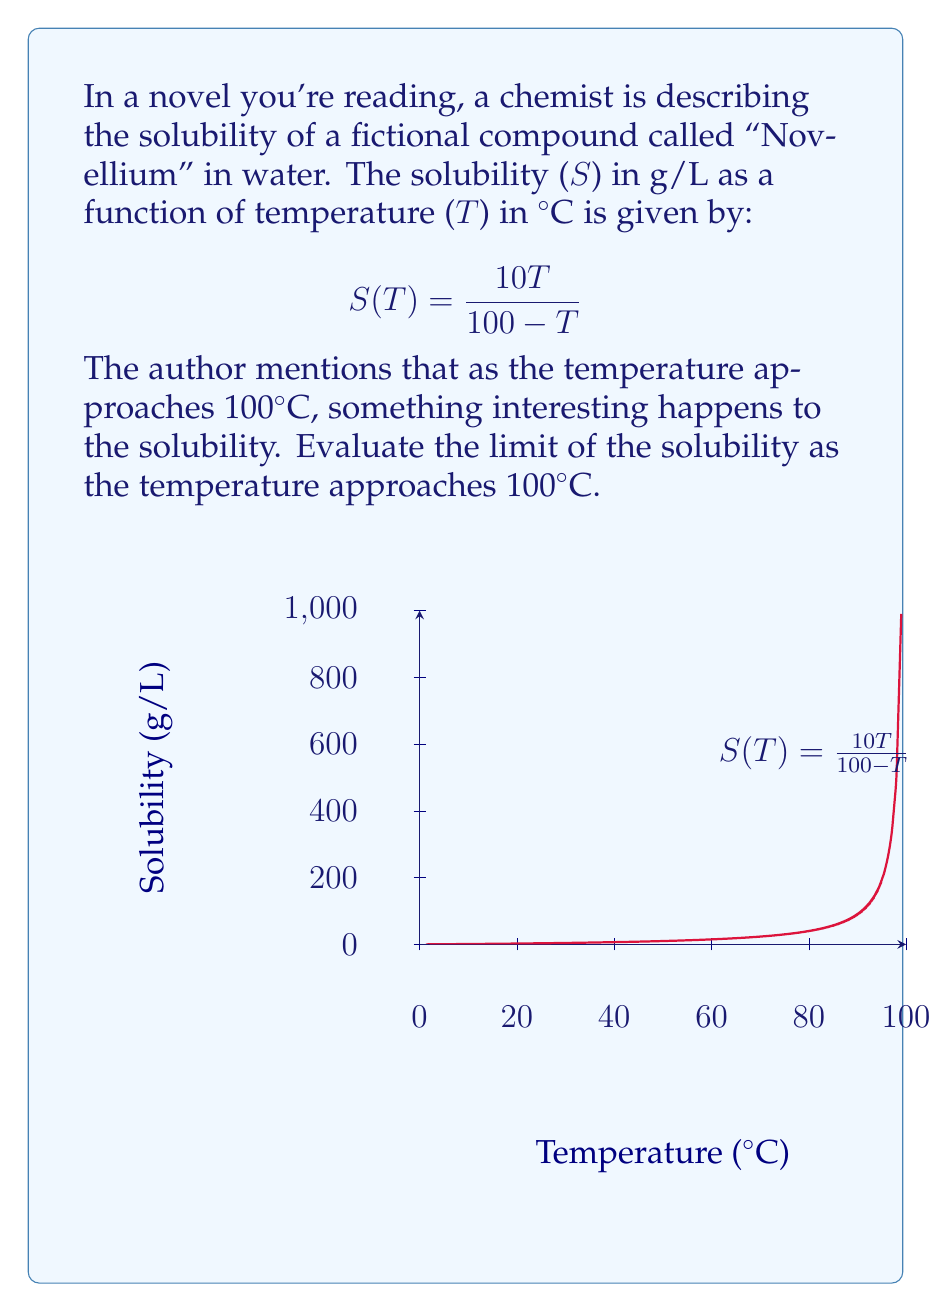Provide a solution to this math problem. To evaluate this limit, let's follow these steps:

1) We need to find $\lim_{T \to 100} S(T)$, where $S(T) = \frac{10T}{100 - T}$

2) As T approaches 100, the denominator (100 - T) approaches 0. This suggests we might have an infinite limit.

3) To confirm, let's use l'Hôpital's rule. First, rewrite the function:

   $$S(T) = \frac{10T}{100 - T} = -10 \cdot \frac{T}{T-100}$$

4) Now, let's take the limit:

   $$\lim_{T \to 100} -10 \cdot \frac{T}{T-100}$$

5) Both numerator and denominator approach 0 as T approaches 100, so we can apply l'Hôpital's rule:

   $$\lim_{T \to 100} -10 \cdot \frac{\frac{d}{dT}T}{\frac{d}{dT}(T-100)} = \lim_{T \to 100} -10 \cdot \frac{1}{1} = -10$$

6) However, we need to be careful. The original function is always positive for T < 100, so this negative limit doesn't make sense in the context of solubility.

7) In fact, as T approaches 100 from the left, the function grows without bound. We can see this by plugging in values very close to but less than 100:

   At T = 99: $S(99) = \frac{990}{1} = 990$ g/L
   At T = 99.9: $S(99.9) = \frac{999}{0.1} = 9990$ g/L

8) Therefore, the correct limit is positive infinity.
Answer: $\lim_{T \to 100^-} S(T) = +\infty$ 